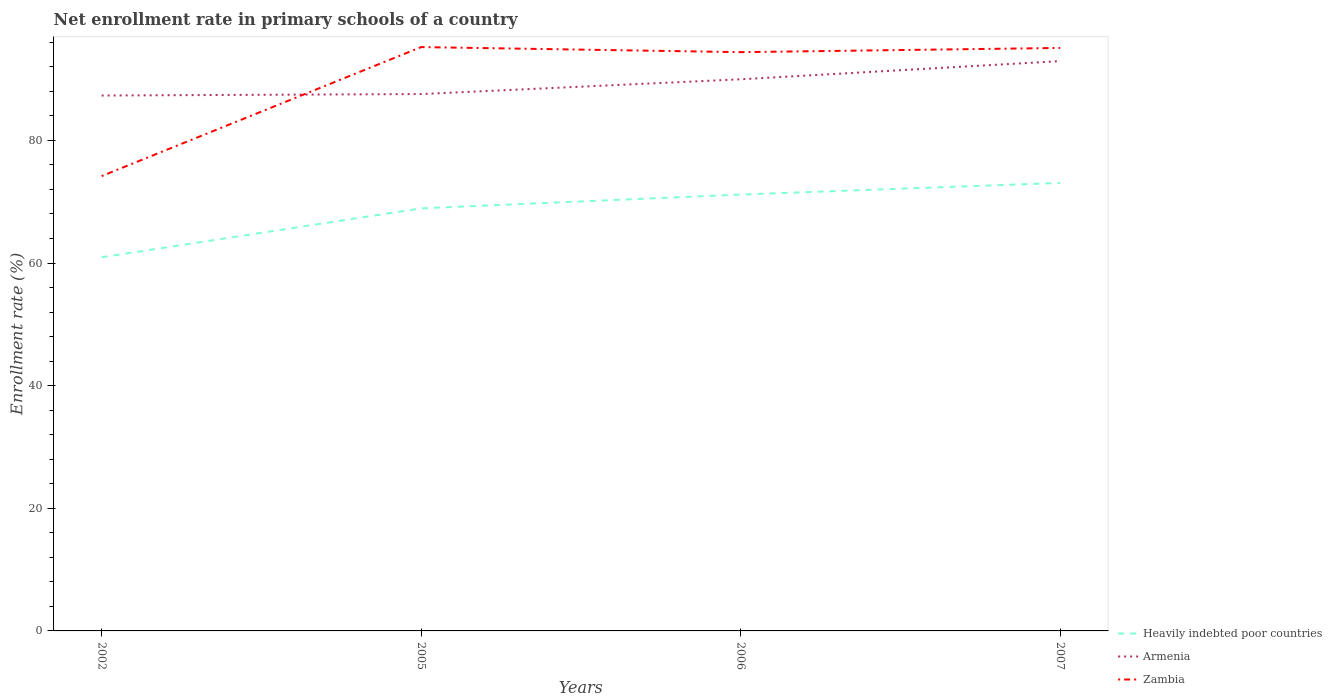Is the number of lines equal to the number of legend labels?
Keep it short and to the point. Yes. Across all years, what is the maximum enrollment rate in primary schools in Heavily indebted poor countries?
Ensure brevity in your answer.  60.94. What is the total enrollment rate in primary schools in Zambia in the graph?
Give a very brief answer. 0.14. What is the difference between the highest and the second highest enrollment rate in primary schools in Armenia?
Provide a short and direct response. 5.61. Is the enrollment rate in primary schools in Zambia strictly greater than the enrollment rate in primary schools in Heavily indebted poor countries over the years?
Provide a succinct answer. No. How many lines are there?
Make the answer very short. 3. Are the values on the major ticks of Y-axis written in scientific E-notation?
Your response must be concise. No. Does the graph contain any zero values?
Offer a terse response. No. Does the graph contain grids?
Provide a short and direct response. No. How many legend labels are there?
Offer a very short reply. 3. What is the title of the graph?
Your response must be concise. Net enrollment rate in primary schools of a country. Does "Andorra" appear as one of the legend labels in the graph?
Make the answer very short. No. What is the label or title of the X-axis?
Keep it short and to the point. Years. What is the label or title of the Y-axis?
Your answer should be very brief. Enrollment rate (%). What is the Enrollment rate (%) in Heavily indebted poor countries in 2002?
Make the answer very short. 60.94. What is the Enrollment rate (%) of Armenia in 2002?
Provide a short and direct response. 87.32. What is the Enrollment rate (%) in Zambia in 2002?
Offer a terse response. 74.18. What is the Enrollment rate (%) in Heavily indebted poor countries in 2005?
Your answer should be compact. 68.92. What is the Enrollment rate (%) in Armenia in 2005?
Make the answer very short. 87.56. What is the Enrollment rate (%) of Zambia in 2005?
Provide a succinct answer. 95.22. What is the Enrollment rate (%) of Heavily indebted poor countries in 2006?
Your answer should be compact. 71.17. What is the Enrollment rate (%) in Armenia in 2006?
Provide a succinct answer. 89.97. What is the Enrollment rate (%) in Zambia in 2006?
Make the answer very short. 94.39. What is the Enrollment rate (%) of Heavily indebted poor countries in 2007?
Provide a succinct answer. 73.07. What is the Enrollment rate (%) of Armenia in 2007?
Offer a very short reply. 92.93. What is the Enrollment rate (%) in Zambia in 2007?
Your answer should be very brief. 95.08. Across all years, what is the maximum Enrollment rate (%) of Heavily indebted poor countries?
Your response must be concise. 73.07. Across all years, what is the maximum Enrollment rate (%) of Armenia?
Provide a succinct answer. 92.93. Across all years, what is the maximum Enrollment rate (%) in Zambia?
Your response must be concise. 95.22. Across all years, what is the minimum Enrollment rate (%) in Heavily indebted poor countries?
Provide a short and direct response. 60.94. Across all years, what is the minimum Enrollment rate (%) in Armenia?
Keep it short and to the point. 87.32. Across all years, what is the minimum Enrollment rate (%) in Zambia?
Your response must be concise. 74.18. What is the total Enrollment rate (%) of Heavily indebted poor countries in the graph?
Your response must be concise. 274.09. What is the total Enrollment rate (%) of Armenia in the graph?
Keep it short and to the point. 357.78. What is the total Enrollment rate (%) in Zambia in the graph?
Your response must be concise. 358.87. What is the difference between the Enrollment rate (%) in Heavily indebted poor countries in 2002 and that in 2005?
Offer a very short reply. -7.98. What is the difference between the Enrollment rate (%) in Armenia in 2002 and that in 2005?
Your answer should be compact. -0.24. What is the difference between the Enrollment rate (%) in Zambia in 2002 and that in 2005?
Give a very brief answer. -21.04. What is the difference between the Enrollment rate (%) in Heavily indebted poor countries in 2002 and that in 2006?
Provide a succinct answer. -10.23. What is the difference between the Enrollment rate (%) in Armenia in 2002 and that in 2006?
Your response must be concise. -2.65. What is the difference between the Enrollment rate (%) in Zambia in 2002 and that in 2006?
Keep it short and to the point. -20.21. What is the difference between the Enrollment rate (%) in Heavily indebted poor countries in 2002 and that in 2007?
Provide a succinct answer. -12.13. What is the difference between the Enrollment rate (%) of Armenia in 2002 and that in 2007?
Provide a short and direct response. -5.61. What is the difference between the Enrollment rate (%) in Zambia in 2002 and that in 2007?
Provide a short and direct response. -20.9. What is the difference between the Enrollment rate (%) in Heavily indebted poor countries in 2005 and that in 2006?
Give a very brief answer. -2.25. What is the difference between the Enrollment rate (%) of Armenia in 2005 and that in 2006?
Give a very brief answer. -2.41. What is the difference between the Enrollment rate (%) in Zambia in 2005 and that in 2006?
Your answer should be compact. 0.82. What is the difference between the Enrollment rate (%) in Heavily indebted poor countries in 2005 and that in 2007?
Provide a succinct answer. -4.15. What is the difference between the Enrollment rate (%) in Armenia in 2005 and that in 2007?
Your answer should be compact. -5.37. What is the difference between the Enrollment rate (%) of Zambia in 2005 and that in 2007?
Ensure brevity in your answer.  0.14. What is the difference between the Enrollment rate (%) of Heavily indebted poor countries in 2006 and that in 2007?
Provide a short and direct response. -1.9. What is the difference between the Enrollment rate (%) of Armenia in 2006 and that in 2007?
Ensure brevity in your answer.  -2.96. What is the difference between the Enrollment rate (%) in Zambia in 2006 and that in 2007?
Offer a very short reply. -0.68. What is the difference between the Enrollment rate (%) of Heavily indebted poor countries in 2002 and the Enrollment rate (%) of Armenia in 2005?
Offer a terse response. -26.62. What is the difference between the Enrollment rate (%) in Heavily indebted poor countries in 2002 and the Enrollment rate (%) in Zambia in 2005?
Make the answer very short. -34.28. What is the difference between the Enrollment rate (%) in Armenia in 2002 and the Enrollment rate (%) in Zambia in 2005?
Your response must be concise. -7.9. What is the difference between the Enrollment rate (%) in Heavily indebted poor countries in 2002 and the Enrollment rate (%) in Armenia in 2006?
Your answer should be compact. -29.03. What is the difference between the Enrollment rate (%) in Heavily indebted poor countries in 2002 and the Enrollment rate (%) in Zambia in 2006?
Your answer should be very brief. -33.46. What is the difference between the Enrollment rate (%) in Armenia in 2002 and the Enrollment rate (%) in Zambia in 2006?
Keep it short and to the point. -7.08. What is the difference between the Enrollment rate (%) of Heavily indebted poor countries in 2002 and the Enrollment rate (%) of Armenia in 2007?
Offer a terse response. -31.99. What is the difference between the Enrollment rate (%) in Heavily indebted poor countries in 2002 and the Enrollment rate (%) in Zambia in 2007?
Provide a short and direct response. -34.14. What is the difference between the Enrollment rate (%) in Armenia in 2002 and the Enrollment rate (%) in Zambia in 2007?
Provide a succinct answer. -7.76. What is the difference between the Enrollment rate (%) in Heavily indebted poor countries in 2005 and the Enrollment rate (%) in Armenia in 2006?
Provide a succinct answer. -21.05. What is the difference between the Enrollment rate (%) in Heavily indebted poor countries in 2005 and the Enrollment rate (%) in Zambia in 2006?
Your answer should be compact. -25.48. What is the difference between the Enrollment rate (%) in Armenia in 2005 and the Enrollment rate (%) in Zambia in 2006?
Your answer should be compact. -6.84. What is the difference between the Enrollment rate (%) of Heavily indebted poor countries in 2005 and the Enrollment rate (%) of Armenia in 2007?
Your response must be concise. -24.02. What is the difference between the Enrollment rate (%) in Heavily indebted poor countries in 2005 and the Enrollment rate (%) in Zambia in 2007?
Keep it short and to the point. -26.16. What is the difference between the Enrollment rate (%) of Armenia in 2005 and the Enrollment rate (%) of Zambia in 2007?
Provide a succinct answer. -7.52. What is the difference between the Enrollment rate (%) in Heavily indebted poor countries in 2006 and the Enrollment rate (%) in Armenia in 2007?
Give a very brief answer. -21.76. What is the difference between the Enrollment rate (%) of Heavily indebted poor countries in 2006 and the Enrollment rate (%) of Zambia in 2007?
Offer a very short reply. -23.91. What is the difference between the Enrollment rate (%) of Armenia in 2006 and the Enrollment rate (%) of Zambia in 2007?
Offer a very short reply. -5.11. What is the average Enrollment rate (%) of Heavily indebted poor countries per year?
Offer a very short reply. 68.52. What is the average Enrollment rate (%) of Armenia per year?
Your response must be concise. 89.44. What is the average Enrollment rate (%) in Zambia per year?
Keep it short and to the point. 89.72. In the year 2002, what is the difference between the Enrollment rate (%) in Heavily indebted poor countries and Enrollment rate (%) in Armenia?
Offer a very short reply. -26.38. In the year 2002, what is the difference between the Enrollment rate (%) of Heavily indebted poor countries and Enrollment rate (%) of Zambia?
Give a very brief answer. -13.24. In the year 2002, what is the difference between the Enrollment rate (%) of Armenia and Enrollment rate (%) of Zambia?
Provide a succinct answer. 13.14. In the year 2005, what is the difference between the Enrollment rate (%) in Heavily indebted poor countries and Enrollment rate (%) in Armenia?
Ensure brevity in your answer.  -18.64. In the year 2005, what is the difference between the Enrollment rate (%) in Heavily indebted poor countries and Enrollment rate (%) in Zambia?
Offer a very short reply. -26.3. In the year 2005, what is the difference between the Enrollment rate (%) in Armenia and Enrollment rate (%) in Zambia?
Your response must be concise. -7.66. In the year 2006, what is the difference between the Enrollment rate (%) in Heavily indebted poor countries and Enrollment rate (%) in Armenia?
Give a very brief answer. -18.8. In the year 2006, what is the difference between the Enrollment rate (%) of Heavily indebted poor countries and Enrollment rate (%) of Zambia?
Offer a very short reply. -23.22. In the year 2006, what is the difference between the Enrollment rate (%) of Armenia and Enrollment rate (%) of Zambia?
Give a very brief answer. -4.43. In the year 2007, what is the difference between the Enrollment rate (%) of Heavily indebted poor countries and Enrollment rate (%) of Armenia?
Offer a terse response. -19.86. In the year 2007, what is the difference between the Enrollment rate (%) of Heavily indebted poor countries and Enrollment rate (%) of Zambia?
Keep it short and to the point. -22.01. In the year 2007, what is the difference between the Enrollment rate (%) in Armenia and Enrollment rate (%) in Zambia?
Your answer should be very brief. -2.15. What is the ratio of the Enrollment rate (%) of Heavily indebted poor countries in 2002 to that in 2005?
Keep it short and to the point. 0.88. What is the ratio of the Enrollment rate (%) in Zambia in 2002 to that in 2005?
Make the answer very short. 0.78. What is the ratio of the Enrollment rate (%) of Heavily indebted poor countries in 2002 to that in 2006?
Give a very brief answer. 0.86. What is the ratio of the Enrollment rate (%) in Armenia in 2002 to that in 2006?
Your response must be concise. 0.97. What is the ratio of the Enrollment rate (%) in Zambia in 2002 to that in 2006?
Make the answer very short. 0.79. What is the ratio of the Enrollment rate (%) of Heavily indebted poor countries in 2002 to that in 2007?
Offer a terse response. 0.83. What is the ratio of the Enrollment rate (%) in Armenia in 2002 to that in 2007?
Provide a short and direct response. 0.94. What is the ratio of the Enrollment rate (%) of Zambia in 2002 to that in 2007?
Offer a very short reply. 0.78. What is the ratio of the Enrollment rate (%) in Heavily indebted poor countries in 2005 to that in 2006?
Your response must be concise. 0.97. What is the ratio of the Enrollment rate (%) of Armenia in 2005 to that in 2006?
Your answer should be very brief. 0.97. What is the ratio of the Enrollment rate (%) in Zambia in 2005 to that in 2006?
Offer a very short reply. 1.01. What is the ratio of the Enrollment rate (%) in Heavily indebted poor countries in 2005 to that in 2007?
Your answer should be compact. 0.94. What is the ratio of the Enrollment rate (%) in Armenia in 2005 to that in 2007?
Provide a short and direct response. 0.94. What is the ratio of the Enrollment rate (%) in Zambia in 2005 to that in 2007?
Give a very brief answer. 1. What is the ratio of the Enrollment rate (%) in Heavily indebted poor countries in 2006 to that in 2007?
Keep it short and to the point. 0.97. What is the ratio of the Enrollment rate (%) in Armenia in 2006 to that in 2007?
Your response must be concise. 0.97. What is the ratio of the Enrollment rate (%) of Zambia in 2006 to that in 2007?
Provide a short and direct response. 0.99. What is the difference between the highest and the second highest Enrollment rate (%) of Heavily indebted poor countries?
Make the answer very short. 1.9. What is the difference between the highest and the second highest Enrollment rate (%) of Armenia?
Your answer should be compact. 2.96. What is the difference between the highest and the second highest Enrollment rate (%) of Zambia?
Your answer should be very brief. 0.14. What is the difference between the highest and the lowest Enrollment rate (%) in Heavily indebted poor countries?
Provide a succinct answer. 12.13. What is the difference between the highest and the lowest Enrollment rate (%) in Armenia?
Ensure brevity in your answer.  5.61. What is the difference between the highest and the lowest Enrollment rate (%) of Zambia?
Make the answer very short. 21.04. 